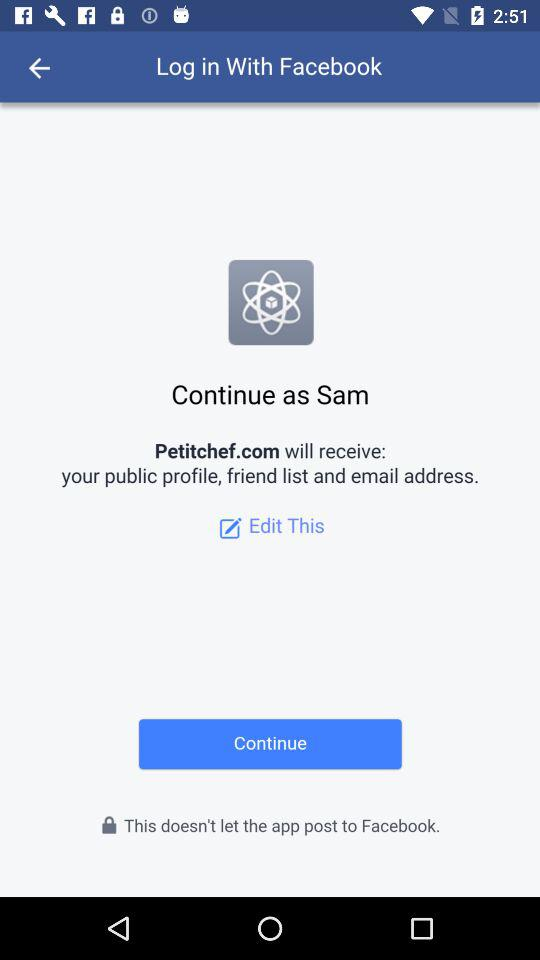What application is asking for permission? The application asking for permission is "Petitchef.com". 